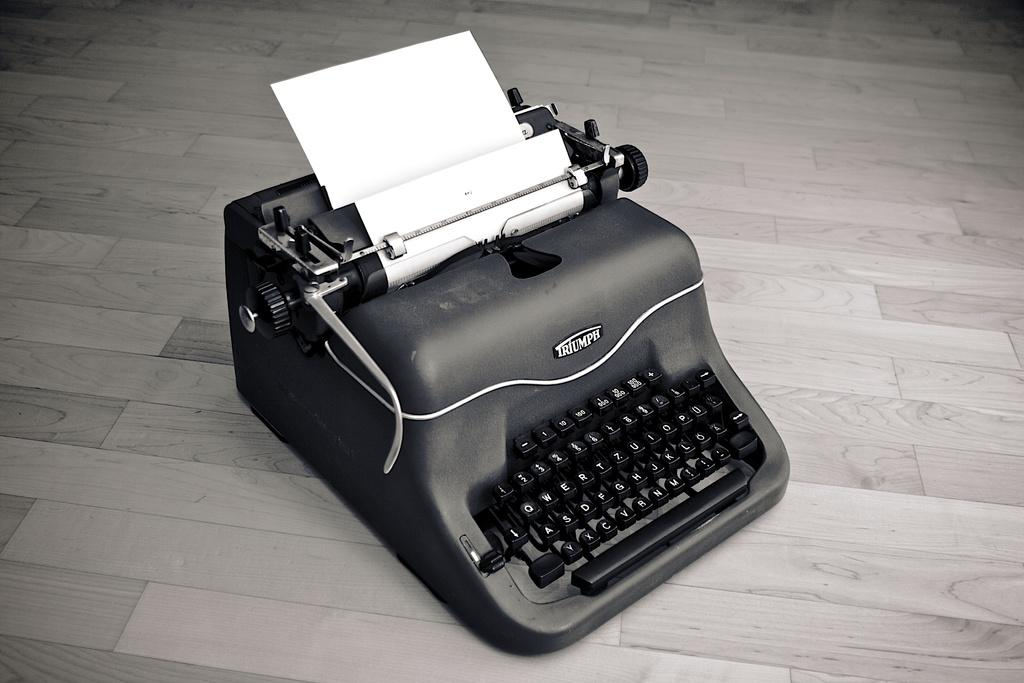<image>
Offer a succinct explanation of the picture presented. Small black Triumph typewriter on a wooden floor. 